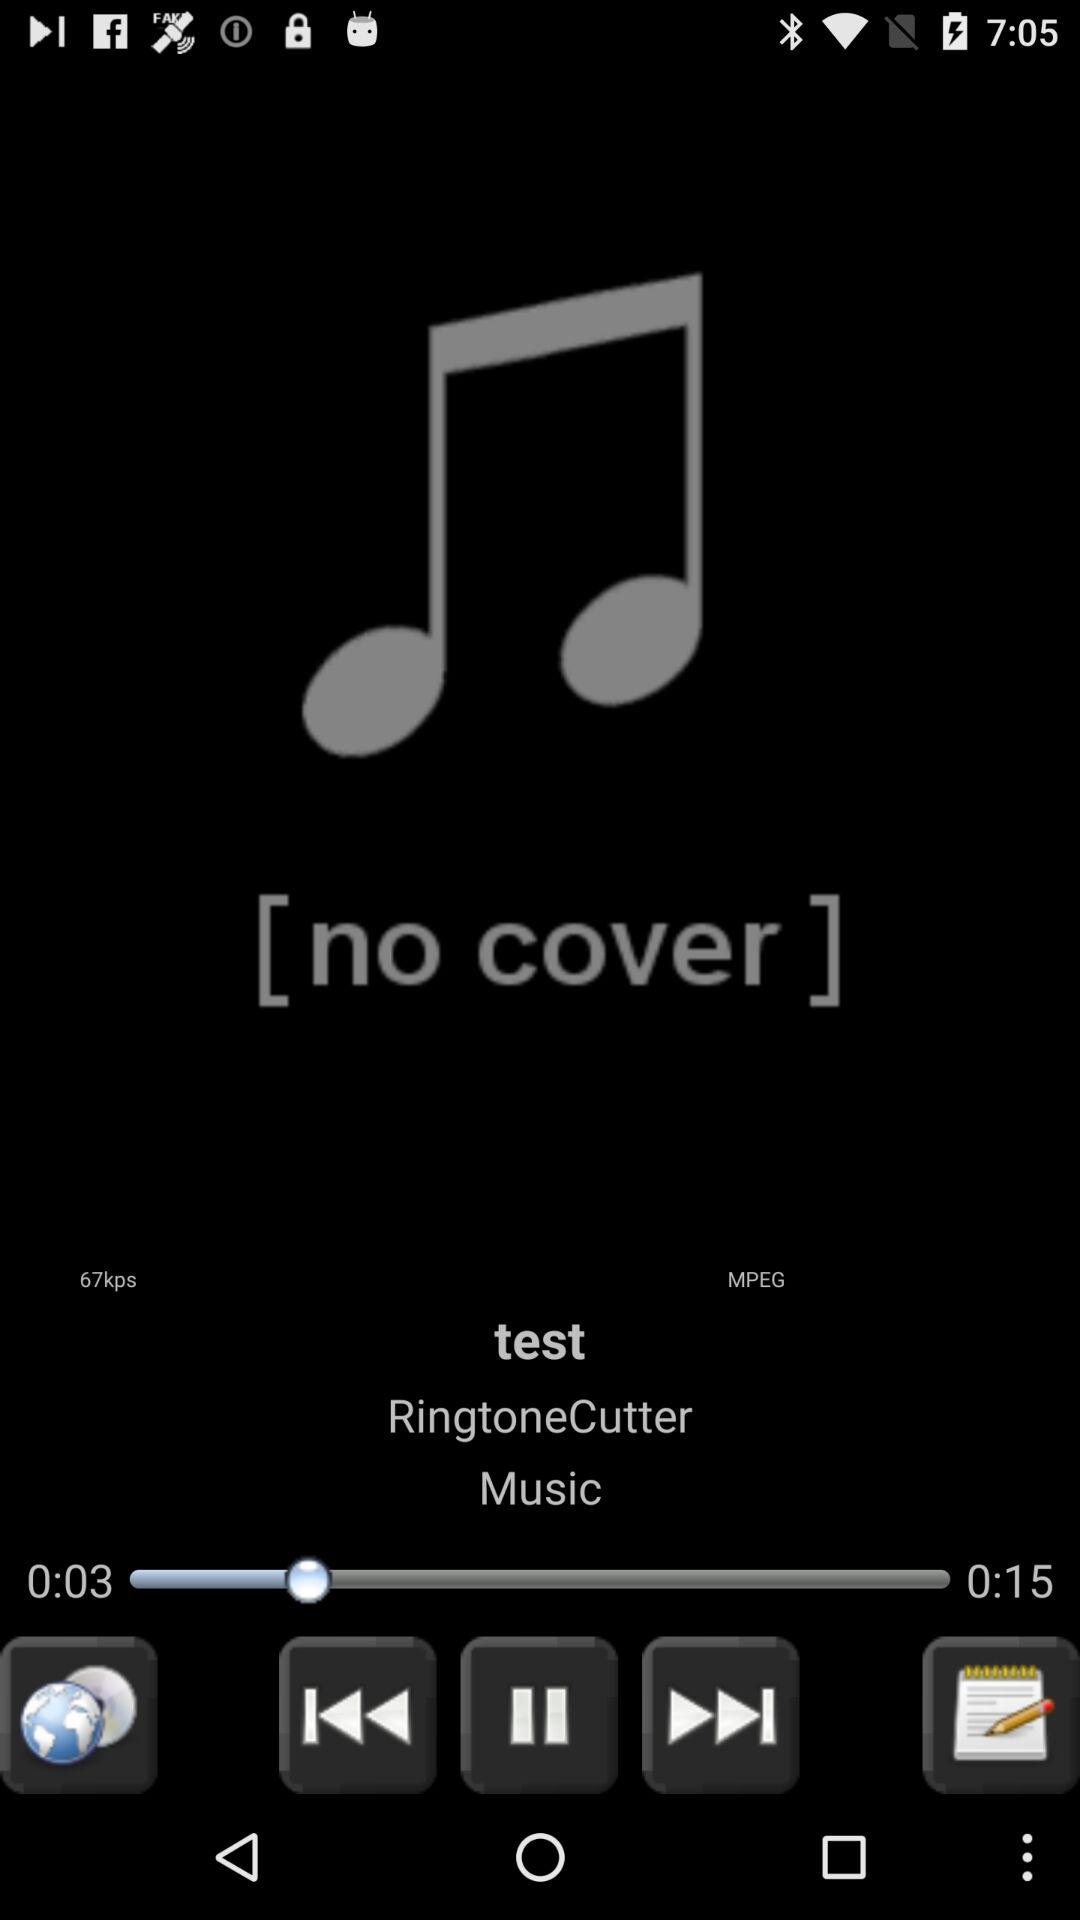What is the difference in time between the current and end time?
Answer the question using a single word or phrase. 0:12 